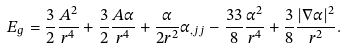<formula> <loc_0><loc_0><loc_500><loc_500>E _ { g } & = \frac { 3 } { 2 } \frac { A ^ { 2 } } { r ^ { 4 } } + \frac { 3 } { 2 } \frac { A \alpha } { r ^ { 4 } } + \frac { \alpha } { 2 r ^ { 2 } } \alpha _ { , j j } - \frac { 3 3 } { 8 } \frac { \alpha ^ { 2 } } { r ^ { 4 } } + \frac { 3 } { 8 } \frac { | \nabla \alpha | ^ { 2 } } { r ^ { 2 } } .</formula> 